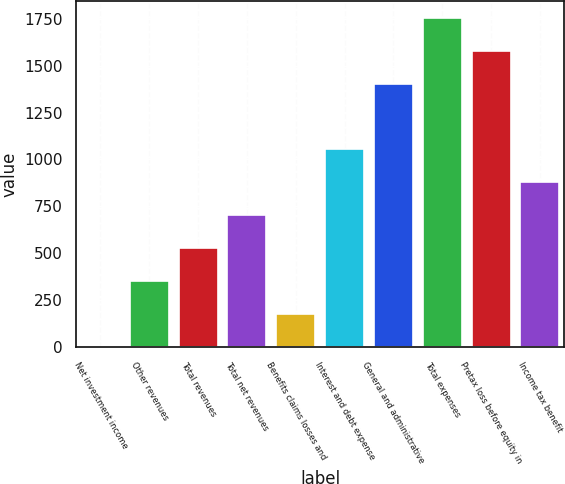Convert chart to OTSL. <chart><loc_0><loc_0><loc_500><loc_500><bar_chart><fcel>Net investment income<fcel>Other revenues<fcel>Total revenues<fcel>Total net revenues<fcel>Benefits claims losses and<fcel>Interest and debt expense<fcel>General and administrative<fcel>Total expenses<fcel>Pretax loss before equity in<fcel>Income tax benefit<nl><fcel>2<fcel>352.4<fcel>527.6<fcel>702.8<fcel>177.2<fcel>1053.2<fcel>1403.6<fcel>1754<fcel>1578.8<fcel>878<nl></chart> 